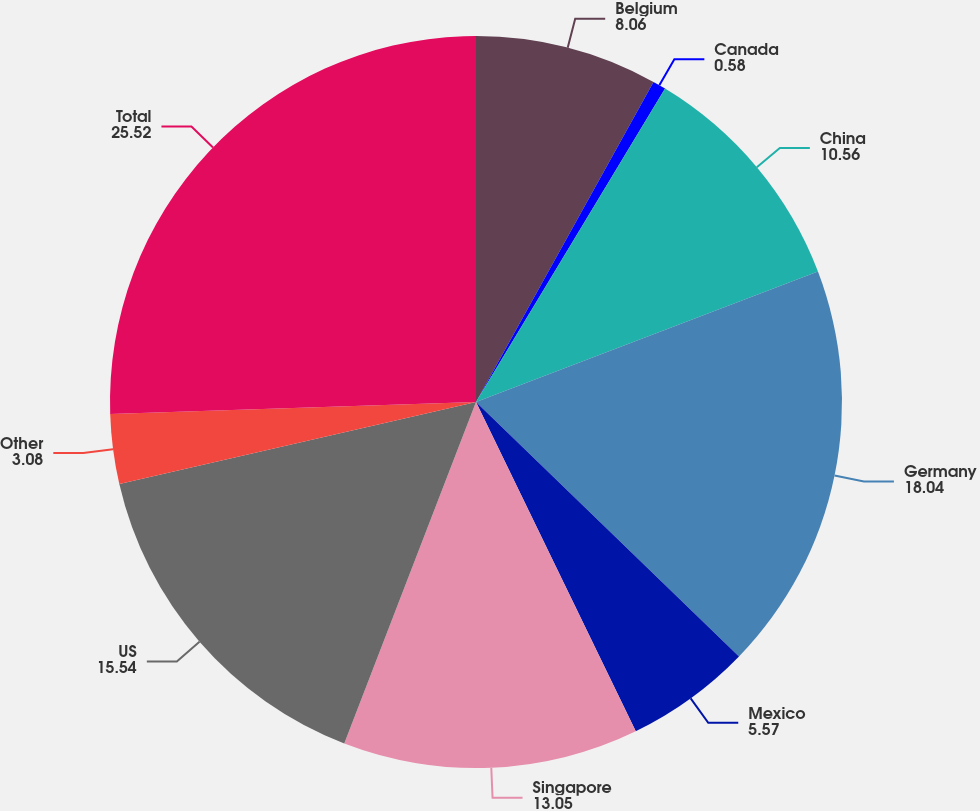Convert chart. <chart><loc_0><loc_0><loc_500><loc_500><pie_chart><fcel>Belgium<fcel>Canada<fcel>China<fcel>Germany<fcel>Mexico<fcel>Singapore<fcel>US<fcel>Other<fcel>Total<nl><fcel>8.06%<fcel>0.58%<fcel>10.56%<fcel>18.04%<fcel>5.57%<fcel>13.05%<fcel>15.54%<fcel>3.08%<fcel>25.52%<nl></chart> 